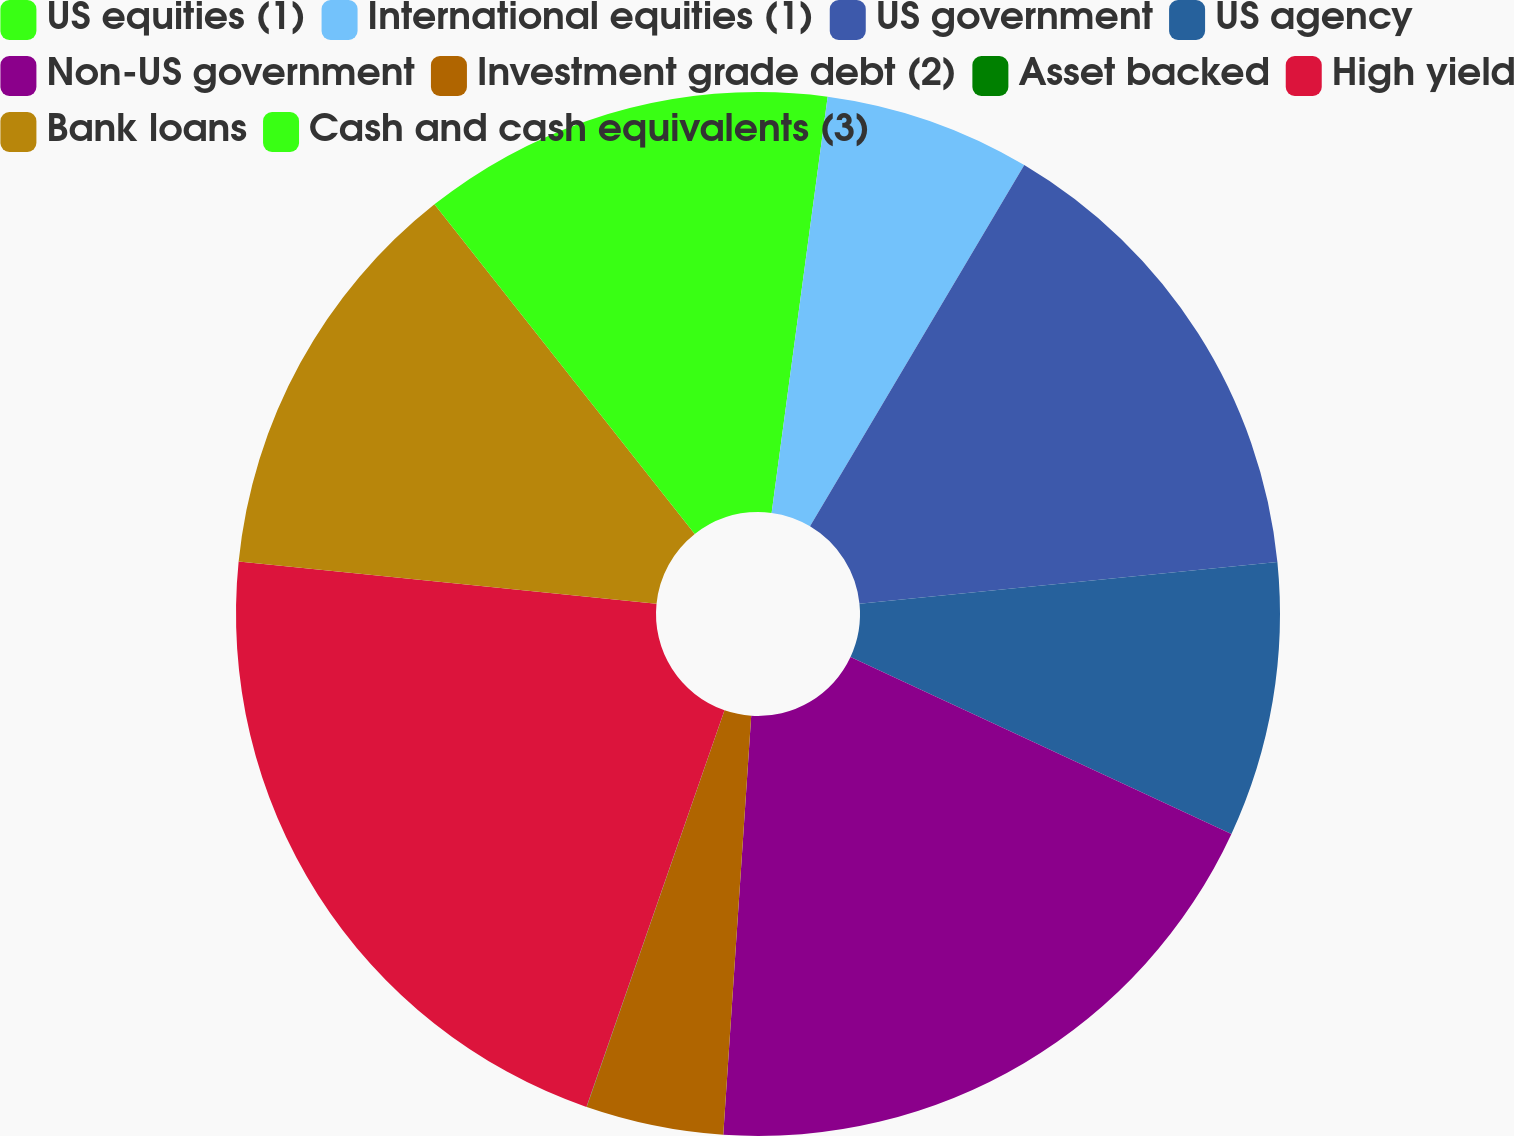<chart> <loc_0><loc_0><loc_500><loc_500><pie_chart><fcel>US equities (1)<fcel>International equities (1)<fcel>US government<fcel>US agency<fcel>Non-US government<fcel>Investment grade debt (2)<fcel>Asset backed<fcel>High yield<fcel>Bank loans<fcel>Cash and cash equivalents (3)<nl><fcel>2.13%<fcel>6.39%<fcel>14.89%<fcel>8.51%<fcel>19.14%<fcel>4.26%<fcel>0.01%<fcel>21.27%<fcel>12.76%<fcel>10.64%<nl></chart> 